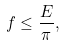<formula> <loc_0><loc_0><loc_500><loc_500>f \leq \frac { E } { \pi } ,</formula> 